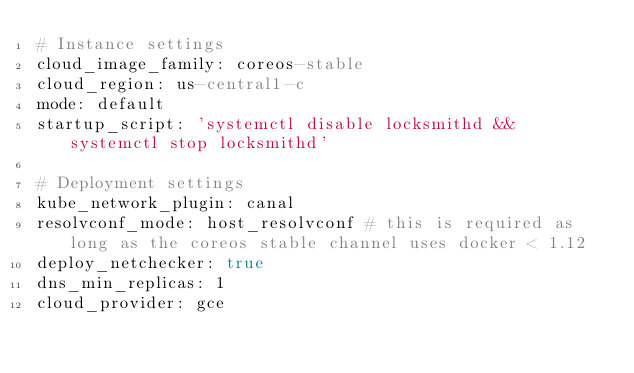<code> <loc_0><loc_0><loc_500><loc_500><_YAML_># Instance settings
cloud_image_family: coreos-stable
cloud_region: us-central1-c
mode: default
startup_script: 'systemctl disable locksmithd && systemctl stop locksmithd'

# Deployment settings
kube_network_plugin: canal
resolvconf_mode: host_resolvconf # this is required as long as the coreos stable channel uses docker < 1.12
deploy_netchecker: true
dns_min_replicas: 1
cloud_provider: gce
</code> 